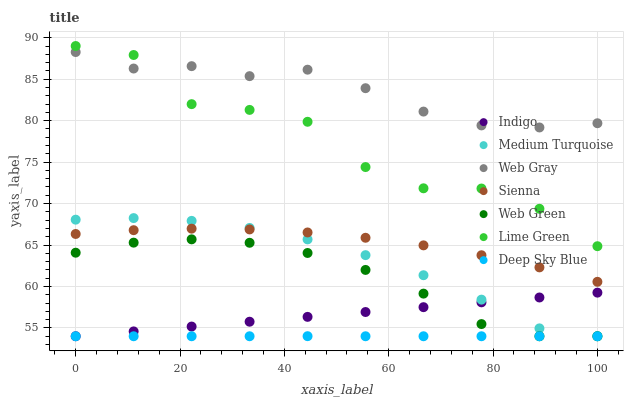Does Deep Sky Blue have the minimum area under the curve?
Answer yes or no. Yes. Does Web Gray have the maximum area under the curve?
Answer yes or no. Yes. Does Indigo have the minimum area under the curve?
Answer yes or no. No. Does Indigo have the maximum area under the curve?
Answer yes or no. No. Is Indigo the smoothest?
Answer yes or no. Yes. Is Lime Green the roughest?
Answer yes or no. Yes. Is Deep Sky Blue the smoothest?
Answer yes or no. No. Is Deep Sky Blue the roughest?
Answer yes or no. No. Does Indigo have the lowest value?
Answer yes or no. Yes. Does Sienna have the lowest value?
Answer yes or no. No. Does Lime Green have the highest value?
Answer yes or no. Yes. Does Indigo have the highest value?
Answer yes or no. No. Is Medium Turquoise less than Web Gray?
Answer yes or no. Yes. Is Lime Green greater than Web Green?
Answer yes or no. Yes. Does Sienna intersect Medium Turquoise?
Answer yes or no. Yes. Is Sienna less than Medium Turquoise?
Answer yes or no. No. Is Sienna greater than Medium Turquoise?
Answer yes or no. No. Does Medium Turquoise intersect Web Gray?
Answer yes or no. No. 